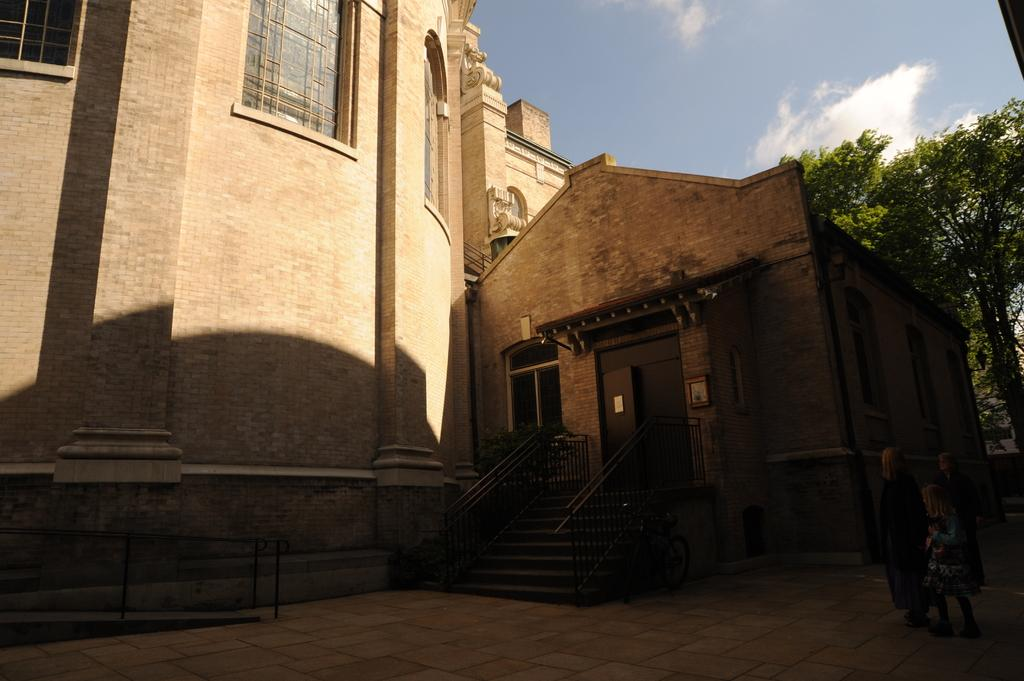How many people are present in the image? There are three people on the ground in the image. What architectural feature can be seen in the image? There are steps in the image. What type of natural elements are present in the image? There are trees in the image. What type of structures are visible in the image? There are buildings with windows in the image. What type of openings are present in the buildings? There are doors in the image. What other objects can be seen in the image? There are some objects in the image. What is visible in the background of the image? The sky is visible in the background of the image. Can you tell me how many kitties are playing with a star in the image? There are no kitties or stars present in the image. What type of worm can be seen crawling on the ground in the image? There are no worms present in the image. 